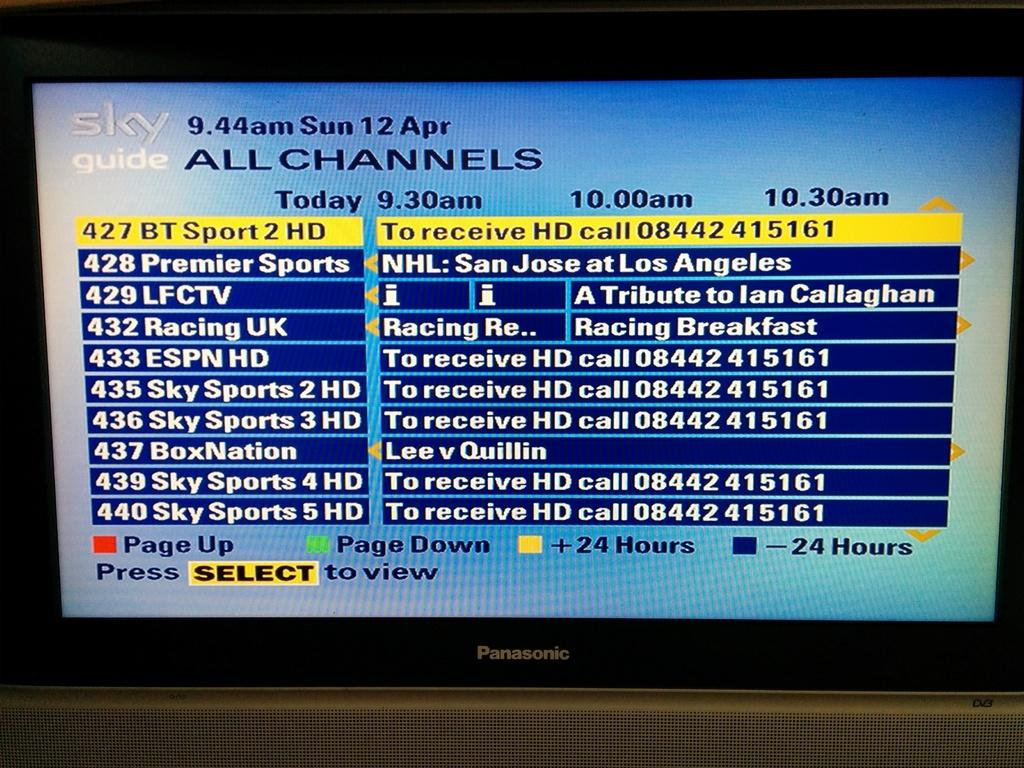<image>
Describe the image concisely. A Sky Guide display lists Sky Sports and ESPN options. 